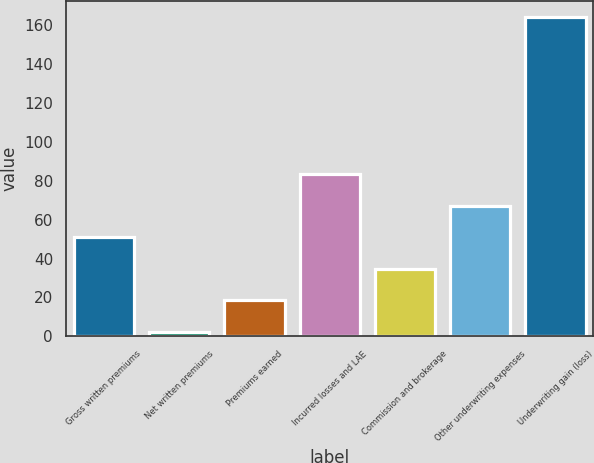<chart> <loc_0><loc_0><loc_500><loc_500><bar_chart><fcel>Gross written premiums<fcel>Net written premiums<fcel>Premiums earned<fcel>Incurred losses and LAE<fcel>Commission and brokerage<fcel>Other underwriting expenses<fcel>Underwriting gain (loss)<nl><fcel>50.94<fcel>2.4<fcel>18.58<fcel>83.3<fcel>34.76<fcel>67.12<fcel>164.2<nl></chart> 